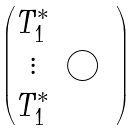Convert formula to latex. <formula><loc_0><loc_0><loc_500><loc_500>\begin{pmatrix} T _ { 1 } ^ { \ast } & & \\ \vdots & \bigcirc & \\ T _ { 1 } ^ { \ast } & & \end{pmatrix}</formula> 